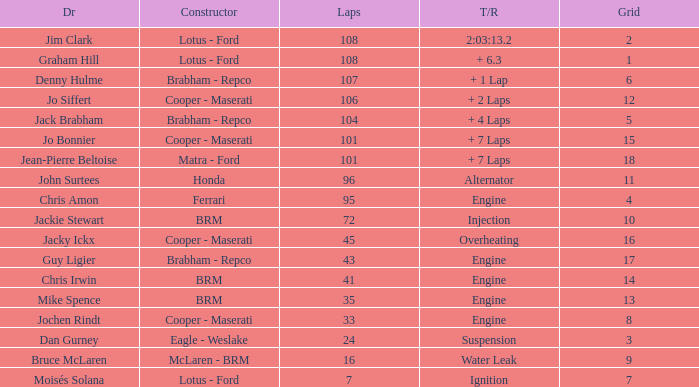What was the constructor when there were 95 laps and a grid less than 15? Ferrari. 